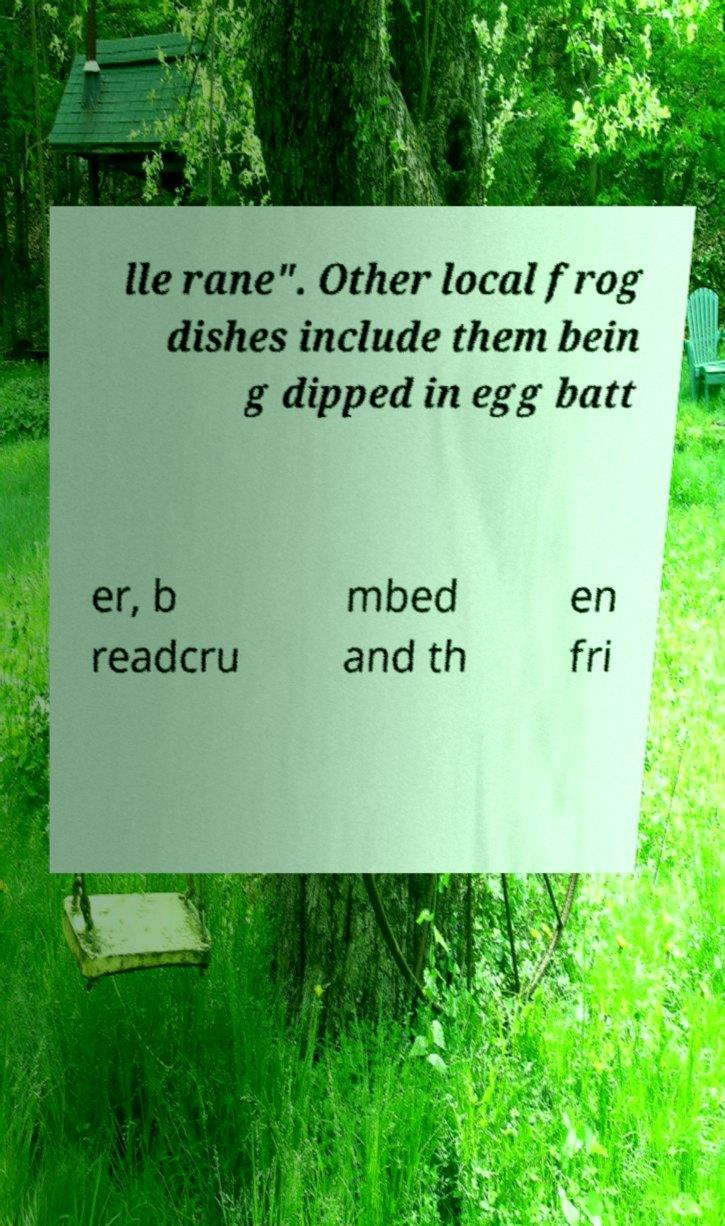There's text embedded in this image that I need extracted. Can you transcribe it verbatim? lle rane". Other local frog dishes include them bein g dipped in egg batt er, b readcru mbed and th en fri 